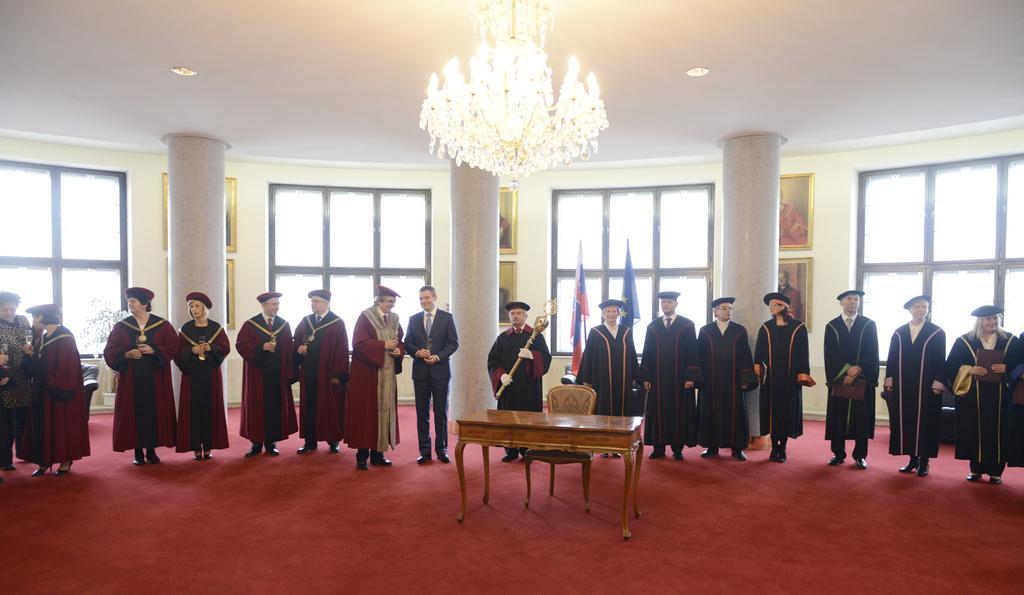In one or two sentences, can you explain what this image depicts? In this image there are group of people who are standing in front of them there is one table and chair and on the top there is a ceiling and lights and one chandelier is there. On the background there are some windows photo frames and some flags are there and on the floor there is one red carpet. 